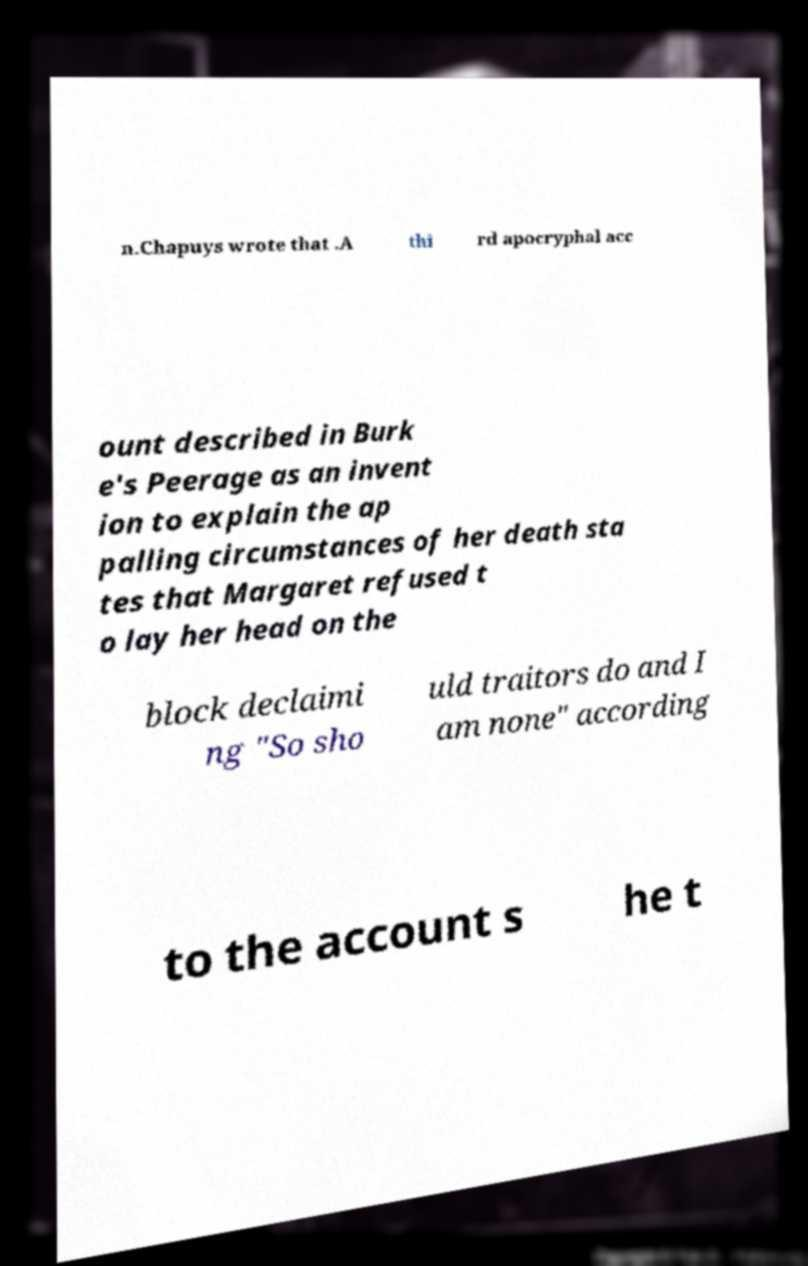Could you extract and type out the text from this image? n.Chapuys wrote that .A thi rd apocryphal acc ount described in Burk e's Peerage as an invent ion to explain the ap palling circumstances of her death sta tes that Margaret refused t o lay her head on the block declaimi ng "So sho uld traitors do and I am none" according to the account s he t 